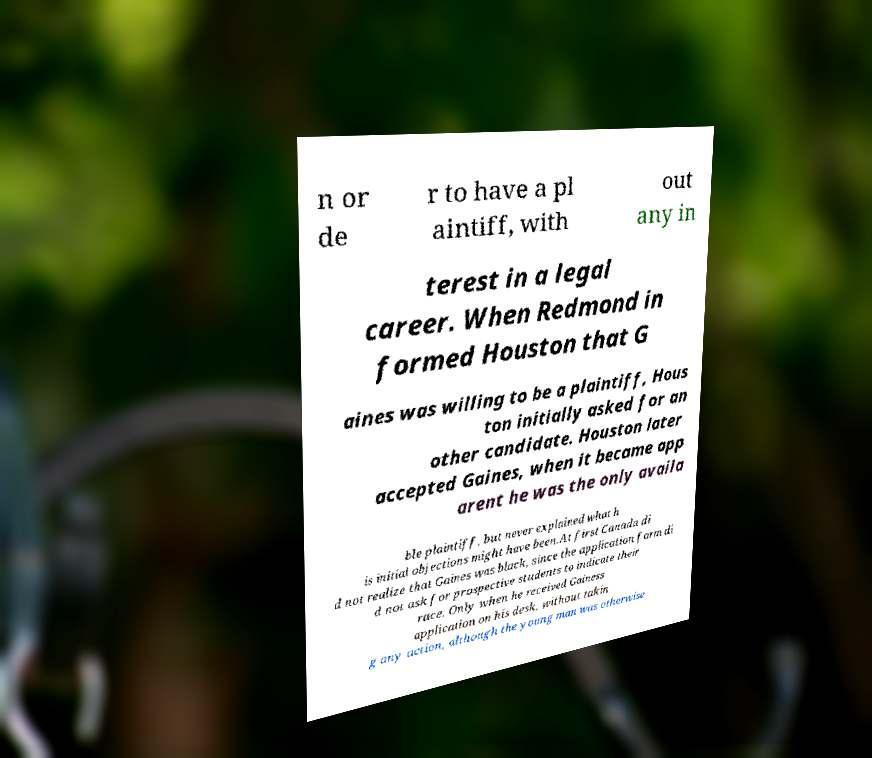Please read and relay the text visible in this image. What does it say? n or de r to have a pl aintiff, with out any in terest in a legal career. When Redmond in formed Houston that G aines was willing to be a plaintiff, Hous ton initially asked for an other candidate. Houston later accepted Gaines, when it became app arent he was the only availa ble plaintiff, but never explained what h is initial objections might have been.At first Canada di d not realize that Gaines was black, since the application form di d not ask for prospective students to indicate their race. Only when he received Gainess application on his desk, without takin g any action, although the young man was otherwise 